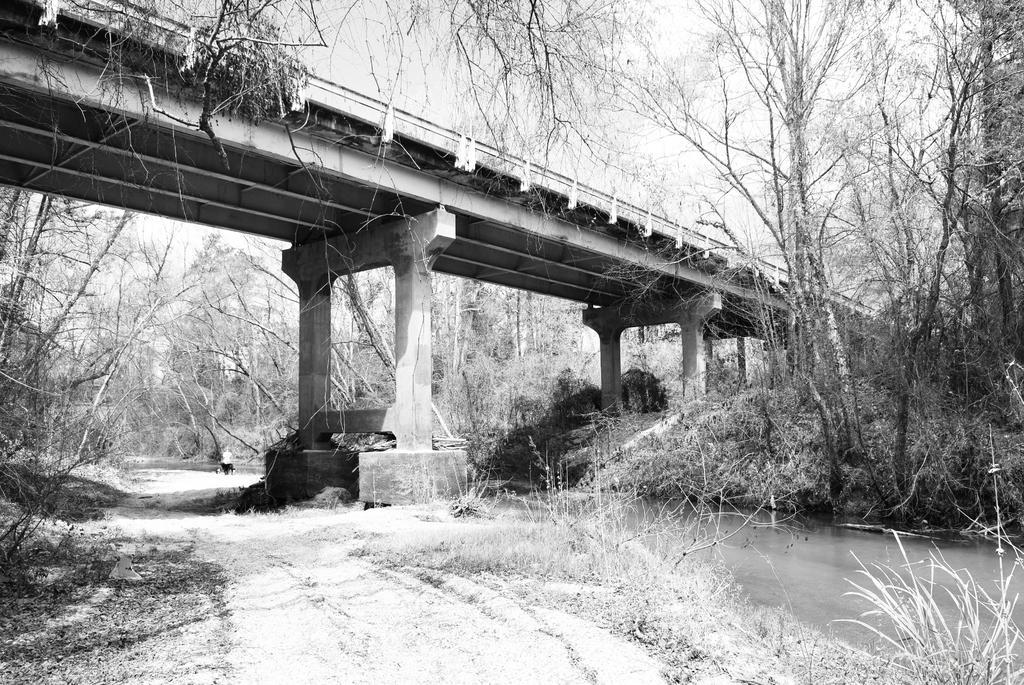In one or two sentences, can you explain what this image depicts? In this image at the center there is water. Beside the water, there is road and we can see a bridge at the center. In the background there are trees and sky. At the bottom there is grass on the surface. 